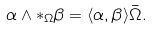Convert formula to latex. <formula><loc_0><loc_0><loc_500><loc_500>\alpha \wedge * _ { \Omega } \beta = \langle \alpha , \beta \rangle \bar { \Omega } .</formula> 